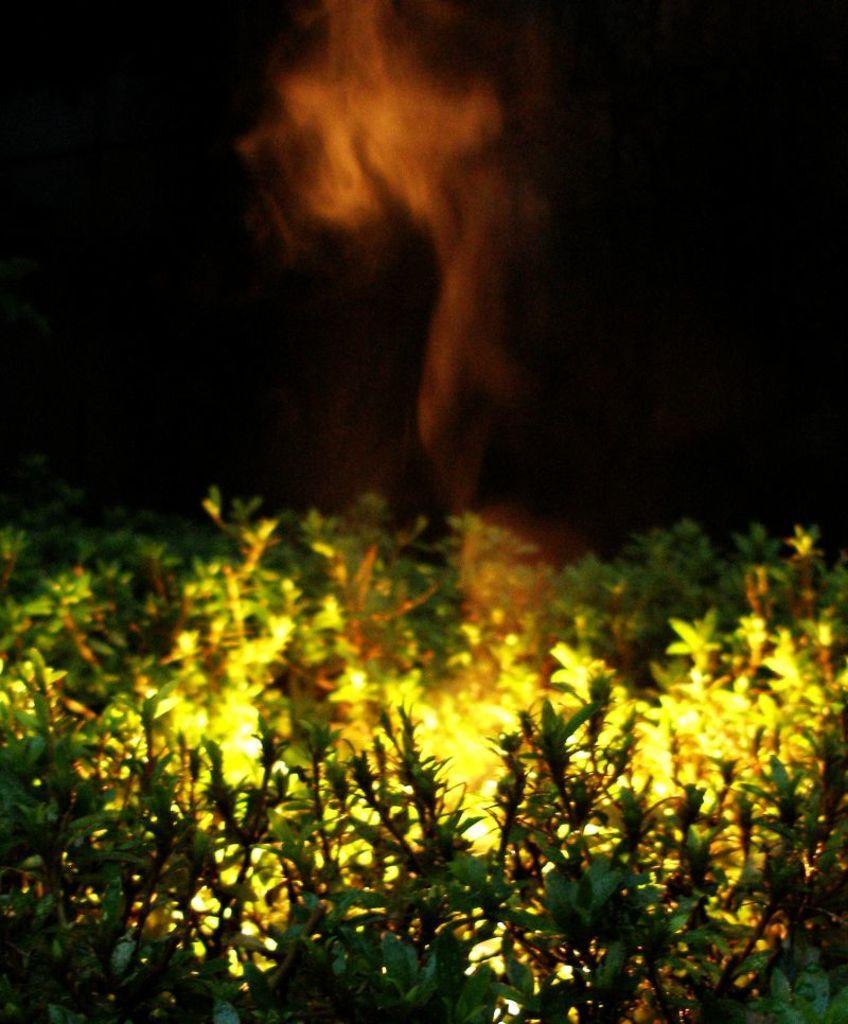Could you give a brief overview of what you see in this image? In this image at the bottom there are some plants, in between the plants there are lights, at the top there is the smoke, backgrounds is dark. 